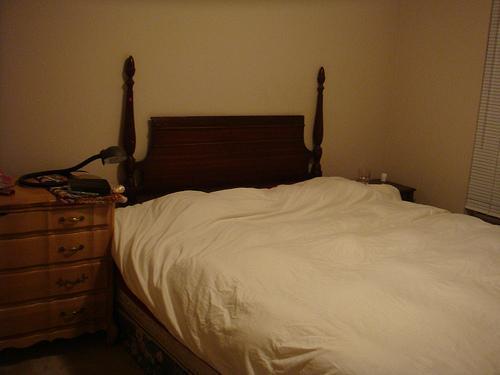How many beds are there?
Give a very brief answer. 1. 